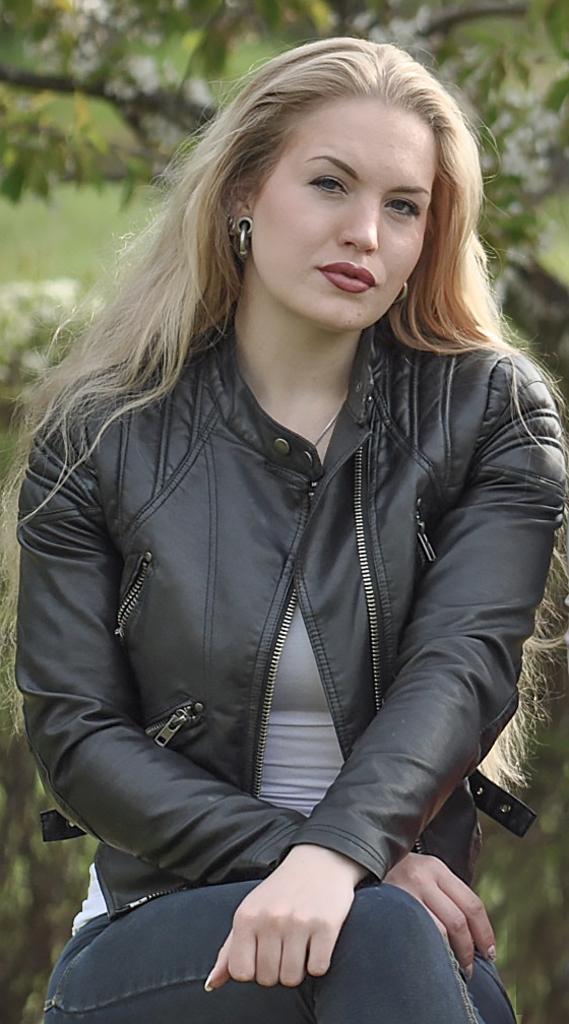In one or two sentences, can you explain what this image depicts? In this picture we can see one woman is sitting and taking picture. 